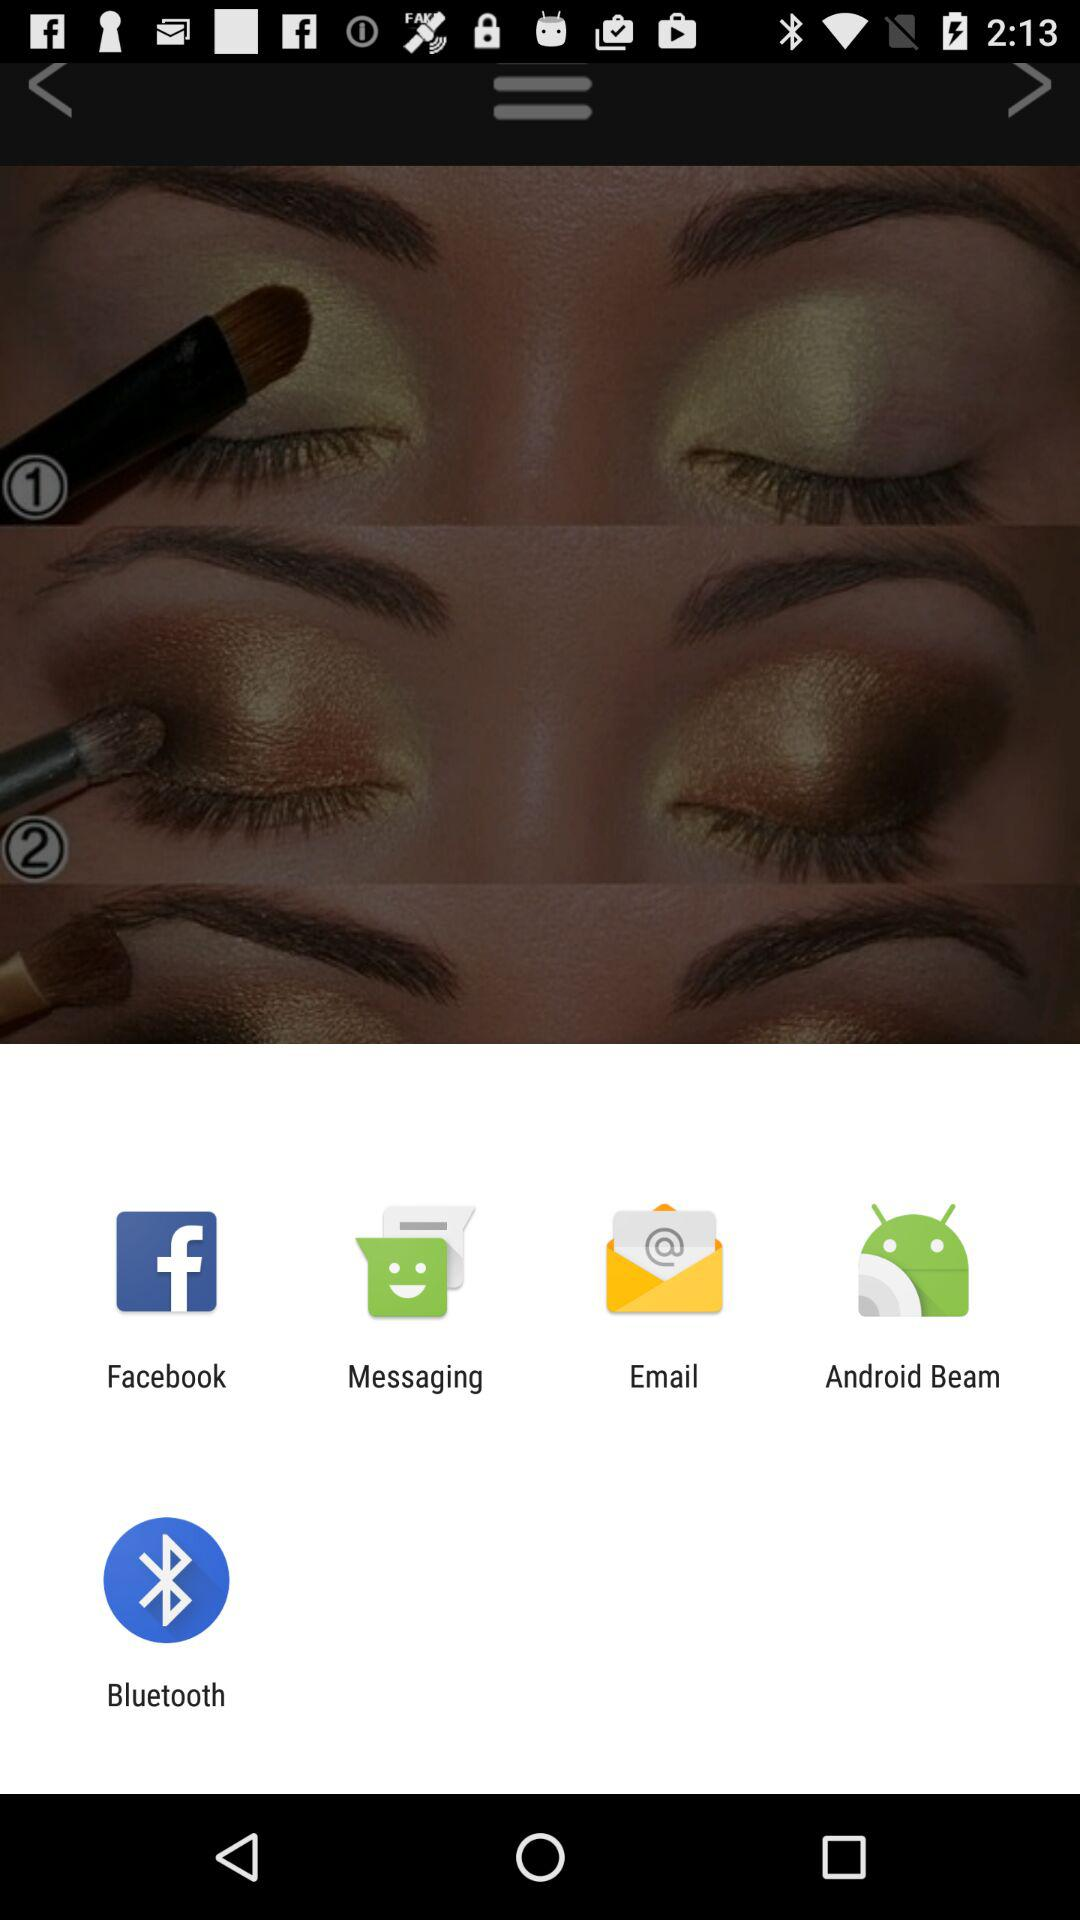What are the sharing options? The sharing options are "Facebook", "Messaging", "Email", "Android Beam" and "Bluetooth". 